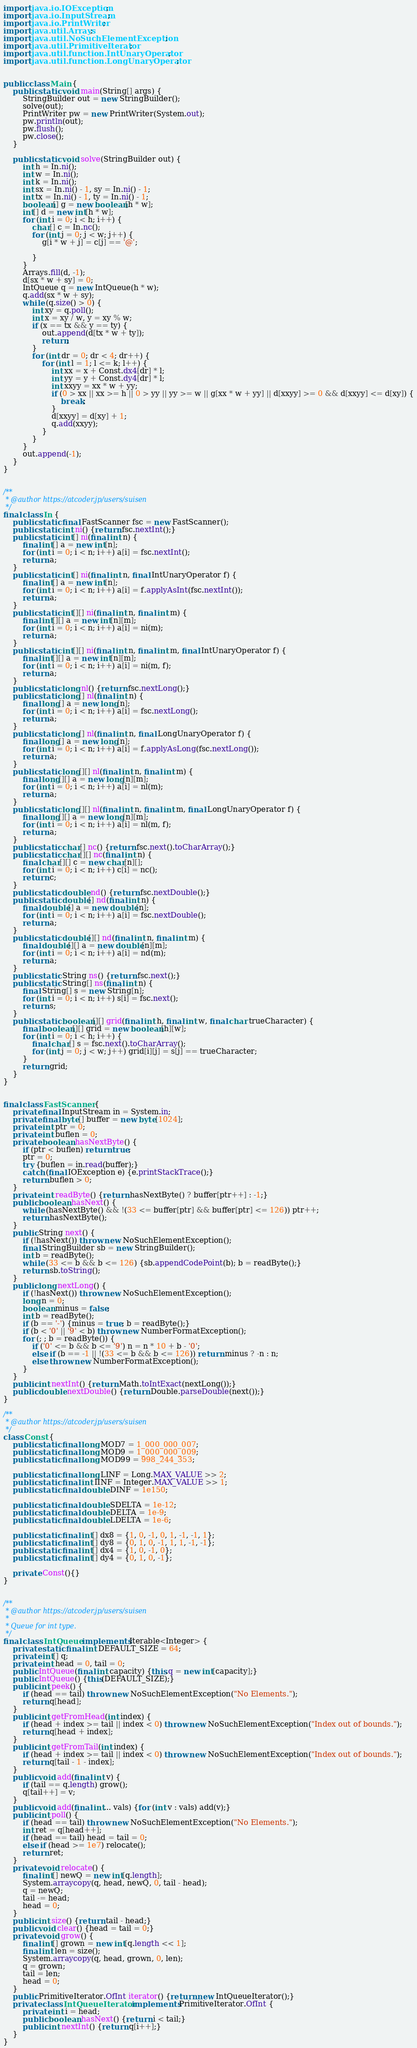<code> <loc_0><loc_0><loc_500><loc_500><_Java_>import java.io.IOException;
import java.io.InputStream;
import java.io.PrintWriter;
import java.util.Arrays;
import java.util.NoSuchElementException;
import java.util.PrimitiveIterator;
import java.util.function.IntUnaryOperator;
import java.util.function.LongUnaryOperator;


public class Main {
    public static void main(String[] args) {
        StringBuilder out = new StringBuilder();
        solve(out);
        PrintWriter pw = new PrintWriter(System.out);
        pw.println(out);
        pw.flush();
        pw.close();
    }

    public static void solve(StringBuilder out) {
        int h = In.ni();
        int w = In.ni();
        int k = In.ni();
        int sx = In.ni() - 1, sy = In.ni() - 1;
        int tx = In.ni() - 1, ty = In.ni() - 1;
        boolean[] g = new boolean[h * w];
        int[] d = new int[h * w];
        for (int i = 0; i < h; i++) {
            char[] c = In.nc();
            for (int j = 0; j < w; j++) {
                g[i * w + j] = c[j] == '@';

            }
        }
        Arrays.fill(d, -1);
        d[sx * w + sy] = 0;
        IntQueue q = new IntQueue(h * w);
        q.add(sx * w + sy);
        while (q.size() > 0) {
            int xy = q.poll();
            int x = xy / w, y = xy % w;
            if (x == tx && y == ty) {
                out.append(d[tx * w + ty]);
                return;
            }
            for (int dr = 0; dr < 4; dr++) {
                for (int l = 1; l <= k; l++) {
                    int xx = x + Const.dx4[dr] * l;
                    int yy = y + Const.dy4[dr] * l;
                    int xxyy = xx * w + yy;
                    if (0 > xx || xx >= h || 0 > yy || yy >= w || g[xx * w + yy] || d[xxyy] >= 0 && d[xxyy] <= d[xy]) {
                        break;
                    }
                    d[xxyy] = d[xy] + 1;
                    q.add(xxyy);
                }
            }
        }
        out.append(-1);
    }
}


/**
 * @author https://atcoder.jp/users/suisen
 */
final class In {
    public static final FastScanner fsc = new FastScanner();
    public static int ni() {return fsc.nextInt();}
    public static int[] ni(final int n) {
        final int[] a = new int[n];
        for (int i = 0; i < n; i++) a[i] = fsc.nextInt();
        return a;
    }
    public static int[] ni(final int n, final IntUnaryOperator f) {
        final int[] a = new int[n];
        for (int i = 0; i < n; i++) a[i] = f.applyAsInt(fsc.nextInt());
        return a;
    }
    public static int[][] ni(final int n, final int m) {
        final int[][] a = new int[n][m];
        for (int i = 0; i < n; i++) a[i] = ni(m);
        return a;
    }
    public static int[][] ni(final int n, final int m, final IntUnaryOperator f) {
        final int[][] a = new int[n][m];
        for (int i = 0; i < n; i++) a[i] = ni(m, f);
        return a;
    }
    public static long nl() {return fsc.nextLong();}
    public static long[] nl(final int n) {
        final long[] a = new long[n];
        for (int i = 0; i < n; i++) a[i] = fsc.nextLong();
        return a;
    }
    public static long[] nl(final int n, final LongUnaryOperator f) {
        final long[] a = new long[n];
        for (int i = 0; i < n; i++) a[i] = f.applyAsLong(fsc.nextLong());
        return a;
    }
    public static long[][] nl(final int n, final int m) {
        final long[][] a = new long[n][m];
        for (int i = 0; i < n; i++) a[i] = nl(m);
        return a;
    }
    public static long[][] nl(final int n, final int m, final LongUnaryOperator f) {
        final long[][] a = new long[n][m];
        for (int i = 0; i < n; i++) a[i] = nl(m, f);
        return a;
    }
    public static char[] nc() {return fsc.next().toCharArray();}
    public static char[][] nc(final int n) {
        final char[][] c = new char[n][];
        for (int i = 0; i < n; i++) c[i] = nc();
        return c;
    }
    public static double nd() {return fsc.nextDouble();}
    public static double[] nd(final int n) {
        final double[] a = new double[n];
        for (int i = 0; i < n; i++) a[i] = fsc.nextDouble();
        return a;
    }
    public static double[][] nd(final int n, final int m) {
        final double[][] a = new double[n][m];
        for (int i = 0; i < n; i++) a[i] = nd(m);
        return a;
    }
    public static String ns() {return fsc.next();}
    public static String[] ns(final int n) {
        final String[] s = new String[n];
        for (int i = 0; i < n; i++) s[i] = fsc.next();
        return s;
    }
    public static boolean[][] grid(final int h, final int w, final char trueCharacter) {
        final boolean[][] grid = new boolean[h][w];
        for (int i = 0; i < h; i++) {
            final char[] s = fsc.next().toCharArray();
            for (int j = 0; j < w; j++) grid[i][j] = s[j] == trueCharacter;
        }
        return grid;
    }
}


final class FastScanner {
    private final InputStream in = System.in;
    private final byte[] buffer = new byte[1024];
    private int ptr = 0;
    private int buflen = 0;
    private boolean hasNextByte() {
        if (ptr < buflen) return true;
        ptr = 0;
        try {buflen = in.read(buffer);}
        catch (final IOException e) {e.printStackTrace();}
        return buflen > 0;
    }
    private int readByte() {return hasNextByte() ? buffer[ptr++] : -1;}
    public boolean hasNext() {
        while (hasNextByte() && !(33 <= buffer[ptr] && buffer[ptr] <= 126)) ptr++;
        return hasNextByte();
    }
    public String next() {
        if (!hasNext()) throw new NoSuchElementException();
        final StringBuilder sb = new StringBuilder();
        int b = readByte();
        while (33 <= b && b <= 126) {sb.appendCodePoint(b); b = readByte();}
        return sb.toString();
    }
    public long nextLong() {
        if (!hasNext()) throw new NoSuchElementException();
        long n = 0;
        boolean minus = false;
        int b = readByte();
        if (b == '-') {minus = true; b = readByte();}
        if (b < '0' || '9' < b) throw new NumberFormatException();
        for (; ; b = readByte()) {
            if ('0' <= b && b <= '9') n = n * 10 + b - '0';
            else if (b == -1 || !(33 <= b && b <= 126)) return minus ? -n : n;
            else throw new NumberFormatException();
        }
    }
    public int nextInt() {return Math.toIntExact(nextLong());}
    public double nextDouble() {return Double.parseDouble(next());}
}

/**
 * @author https://atcoder.jp/users/suisen
 */
class Const {
    public static final long MOD7 = 1_000_000_007;
    public static final long MOD9 = 1_000_000_009;
    public static final long MOD99 = 998_244_353;

    public static final long LINF = Long.MAX_VALUE >> 2;
    public static final int IINF = Integer.MAX_VALUE >> 1;
    public static final double DINF = 1e150;

    public static final double SDELTA = 1e-12;
    public static final double DELTA = 1e-9;
    public static final double LDELTA = 1e-6;

    public static final int[] dx8 = {1, 0, -1, 0, 1, -1, -1, 1};
    public static final int[] dy8 = {0, 1, 0, -1, 1, 1, -1, -1};
    public static final int[] dx4 = {1, 0, -1, 0};
    public static final int[] dy4 = {0, 1, 0, -1};

    private Const(){}
}


/**
 * @author https://atcoder.jp/users/suisen
 * 
 * Queue for int type.
 */
final class IntQueue implements Iterable<Integer> {
    private static final int DEFAULT_SIZE = 64;
    private int[] q;
    private int head = 0, tail = 0;
    public IntQueue(final int capacity) {this.q = new int[capacity];}
    public IntQueue() {this(DEFAULT_SIZE);}
    public int peek() {
        if (head == tail) throw new NoSuchElementException("No Elements.");
        return q[head];
    }
    public int getFromHead(int index) {
        if (head + index >= tail || index < 0) throw new NoSuchElementException("Index out of bounds.");
        return q[head + index];
    }
    public int getFromTail(int index) {
        if (head + index >= tail || index < 0) throw new NoSuchElementException("Index out of bounds.");
        return q[tail - 1 - index];
    }
    public void add(final int v) {
        if (tail == q.length) grow();
        q[tail++] = v;
    }
    public void add(final int... vals) {for (int v : vals) add(v);}
    public int poll() {
        if (head == tail) throw new NoSuchElementException("No Elements.");
        int ret = q[head++];
        if (head == tail) head = tail = 0;
        else if (head >= 1e7) relocate();
        return ret;
    }
    private void relocate() {
        final int[] newQ = new int[q.length];
        System.arraycopy(q, head, newQ, 0, tail - head);
        q = newQ;
        tail -= head;
        head = 0;
    }
    public int size() {return tail - head;}
    public void clear() {head = tail = 0;}
    private void grow() {
        final int[] grown = new int[q.length << 1];
        final int len = size();
        System.arraycopy(q, head, grown, 0, len);
        q = grown;
        tail = len;
        head = 0;
    }
    public PrimitiveIterator.OfInt iterator() {return new IntQueueIterator();}
    private class IntQueueIterator implements PrimitiveIterator.OfInt {
        private int i = head;
        public boolean hasNext() {return i < tail;}
        public int nextInt() {return q[i++];}
    }
}
</code> 